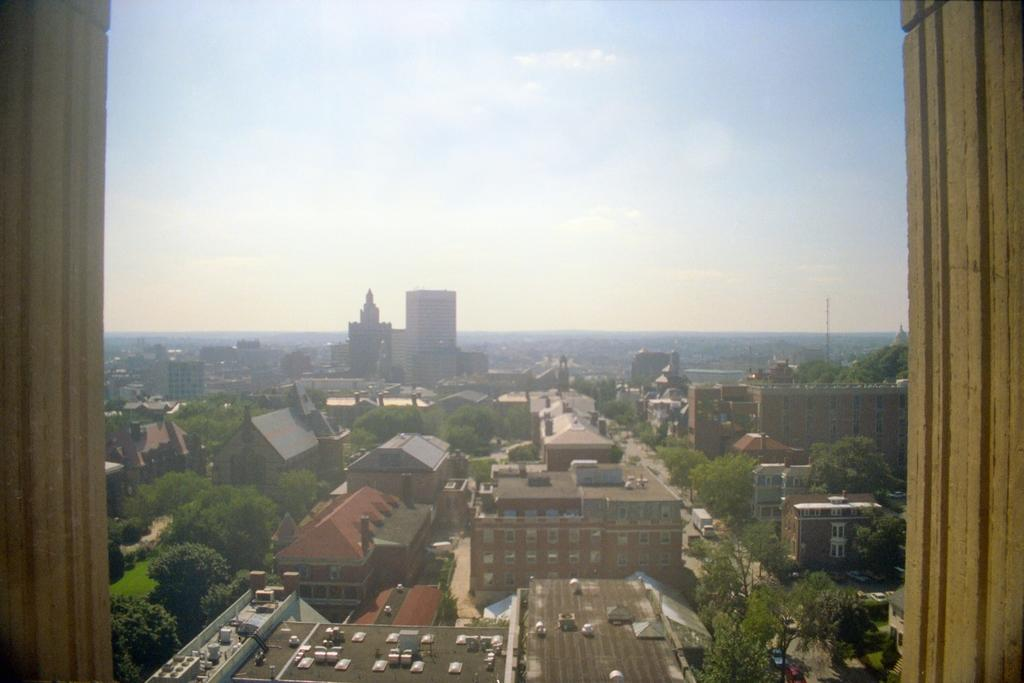What type of structures can be seen in the image? There are buildings in the image. What else can be seen besides the buildings? There are objects, trees, and vehicles on the road in the image. What is visible in the background of the image? The sky is visible in the background of the image. Where is the brain located in the image? There is no brain present in the image. What type of seat can be seen in the image? There is no seat present in the image. 